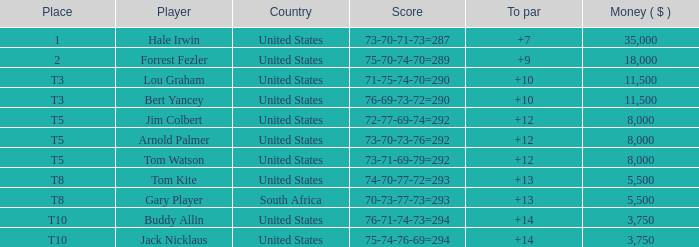In which nation did a score of 72-77-69-74=292 lead to a prize of more than $5,500? United States. Can you parse all the data within this table? {'header': ['Place', 'Player', 'Country', 'Score', 'To par', 'Money ( $ )'], 'rows': [['1', 'Hale Irwin', 'United States', '73-70-71-73=287', '+7', '35,000'], ['2', 'Forrest Fezler', 'United States', '75-70-74-70=289', '+9', '18,000'], ['T3', 'Lou Graham', 'United States', '71-75-74-70=290', '+10', '11,500'], ['T3', 'Bert Yancey', 'United States', '76-69-73-72=290', '+10', '11,500'], ['T5', 'Jim Colbert', 'United States', '72-77-69-74=292', '+12', '8,000'], ['T5', 'Arnold Palmer', 'United States', '73-70-73-76=292', '+12', '8,000'], ['T5', 'Tom Watson', 'United States', '73-71-69-79=292', '+12', '8,000'], ['T8', 'Tom Kite', 'United States', '74-70-77-72=293', '+13', '5,500'], ['T8', 'Gary Player', 'South Africa', '70-73-77-73=293', '+13', '5,500'], ['T10', 'Buddy Allin', 'United States', '76-71-74-73=294', '+14', '3,750'], ['T10', 'Jack Nicklaus', 'United States', '75-74-76-69=294', '+14', '3,750']]} 